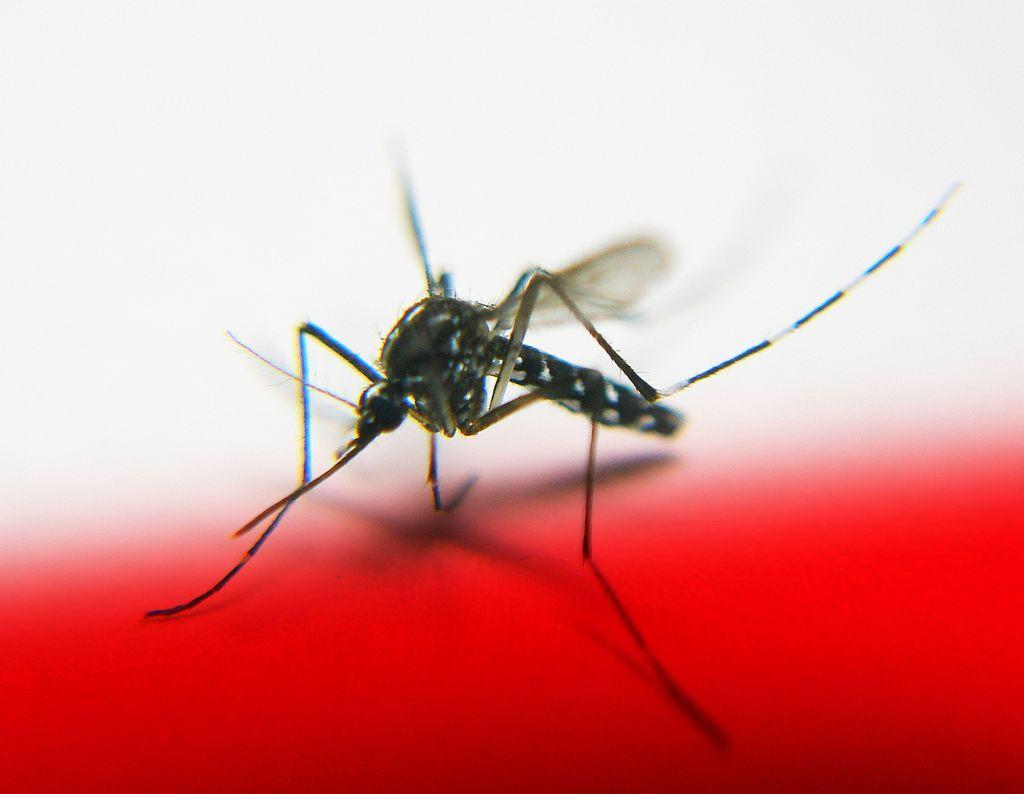Could you give a brief overview of what you see in this image? In this image we can see a mosquito on the red color surface and the background is in white color. 